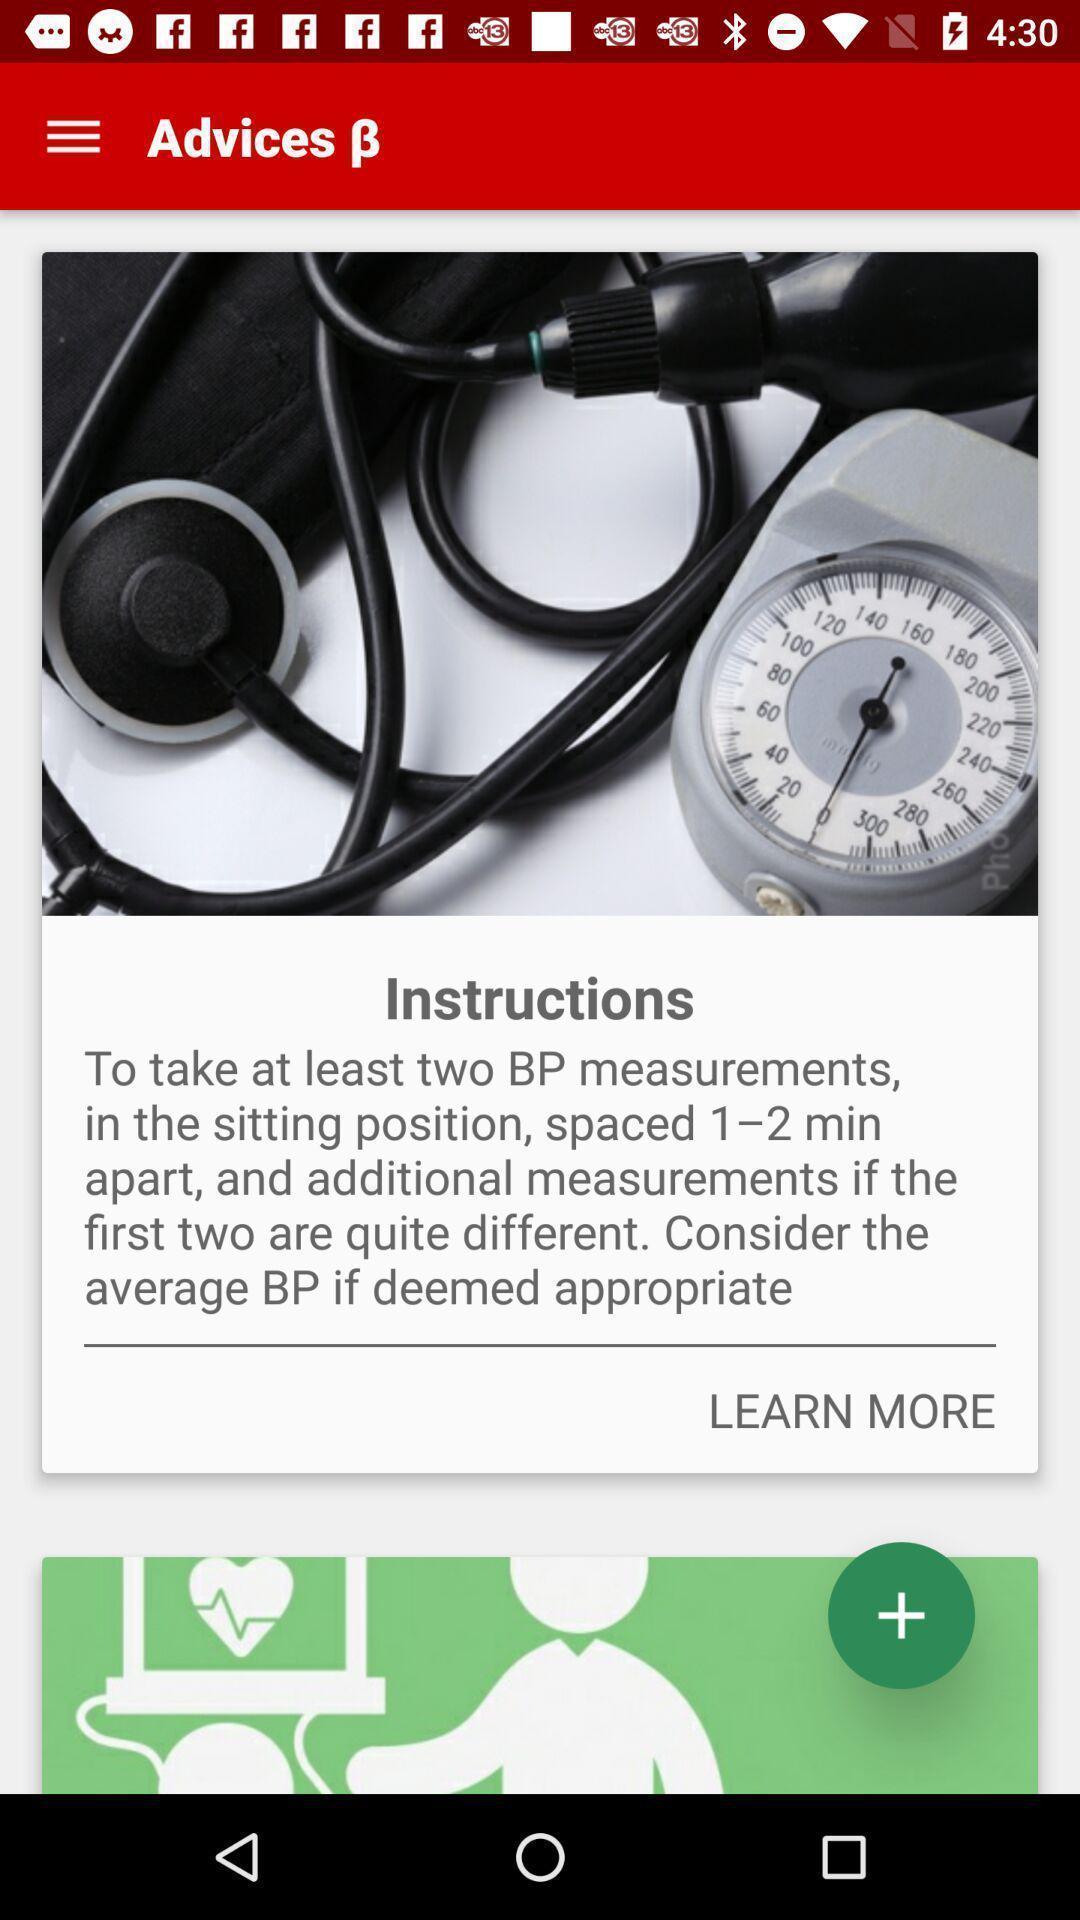What is the overall content of this screenshot? Page showing instructions in an health application. 